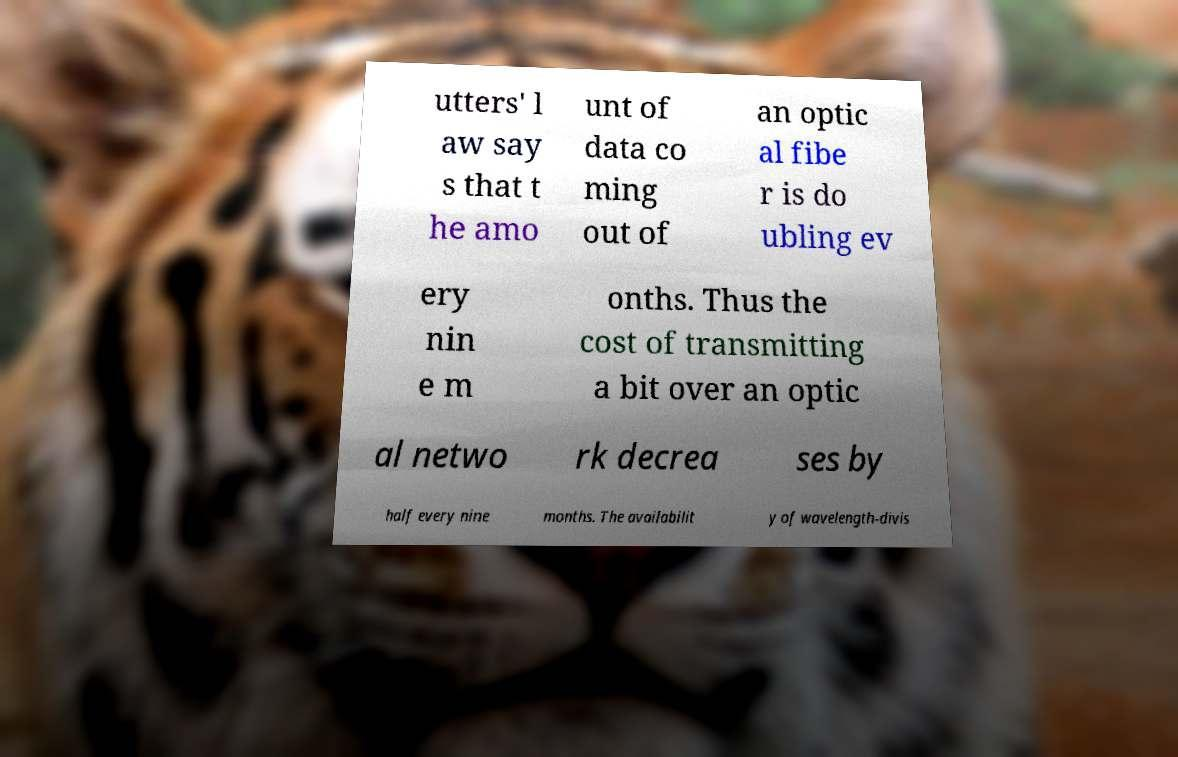There's text embedded in this image that I need extracted. Can you transcribe it verbatim? utters' l aw say s that t he amo unt of data co ming out of an optic al fibe r is do ubling ev ery nin e m onths. Thus the cost of transmitting a bit over an optic al netwo rk decrea ses by half every nine months. The availabilit y of wavelength-divis 